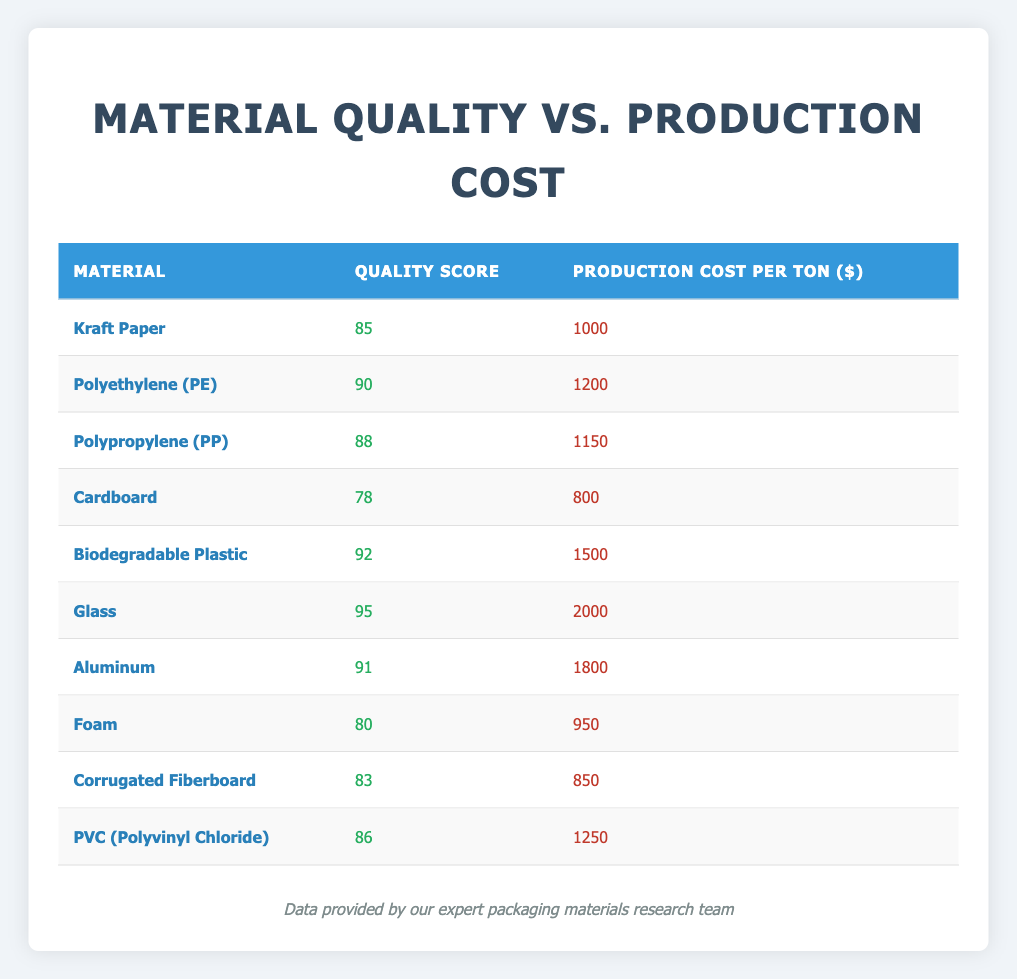What is the production cost per ton of Glass? The table lists the production cost per ton for each material. Looking for the row with "Glass", the corresponding value is 2000 dollars.
Answer: 2000 Which material has the highest quality score? By scanning through the "Quality Score" column, "Glass" has the highest score of 95.
Answer: Glass Calculate the average production cost of the materials listed. First, we sum all the production costs: 1000 + 1200 + 1150 + 800 + 1500 + 2000 + 1800 + 950 + 850 + 1250 = 11600. There are 10 materials, so the average is 11600 / 10 = 1160.
Answer: 1160 Is the quality score of Polypropylene greater than 85? The quality score of Polypropylene is listed as 88, which is greater than 85.
Answer: Yes What is the difference in production cost between Biodegradable Plastic and Cardboard? The production cost of Biodegradable Plastic is 1500 dollars and for Cardboard, it is 800 dollars. The difference is 1500 - 800 = 700 dollars.
Answer: 700 Does any material have a quality score below 80? Checking the "Quality Score" column, the lowest score is 78 for Cardboard, which is below 80.
Answer: Yes If we combine the quality scores of Kraft Paper and Foam, what is the total? The quality score for Kraft Paper is 85, and for Foam, it is 80. Adding these gives us 85 + 80 = 165.
Answer: 165 What is the production cost of the second highest quality material? The second highest quality score is 91 for Aluminum, with a production cost of 1800 dollars.
Answer: 1800 How many materials have a production cost greater than 1000 dollars? The materials with production costs above 1000 are: Polyethylene (1200), Polypropylene (1150), Biodegradable Plastic (1500), Glass (2000), and Aluminum (1800), totaling 5 materials.
Answer: 5 